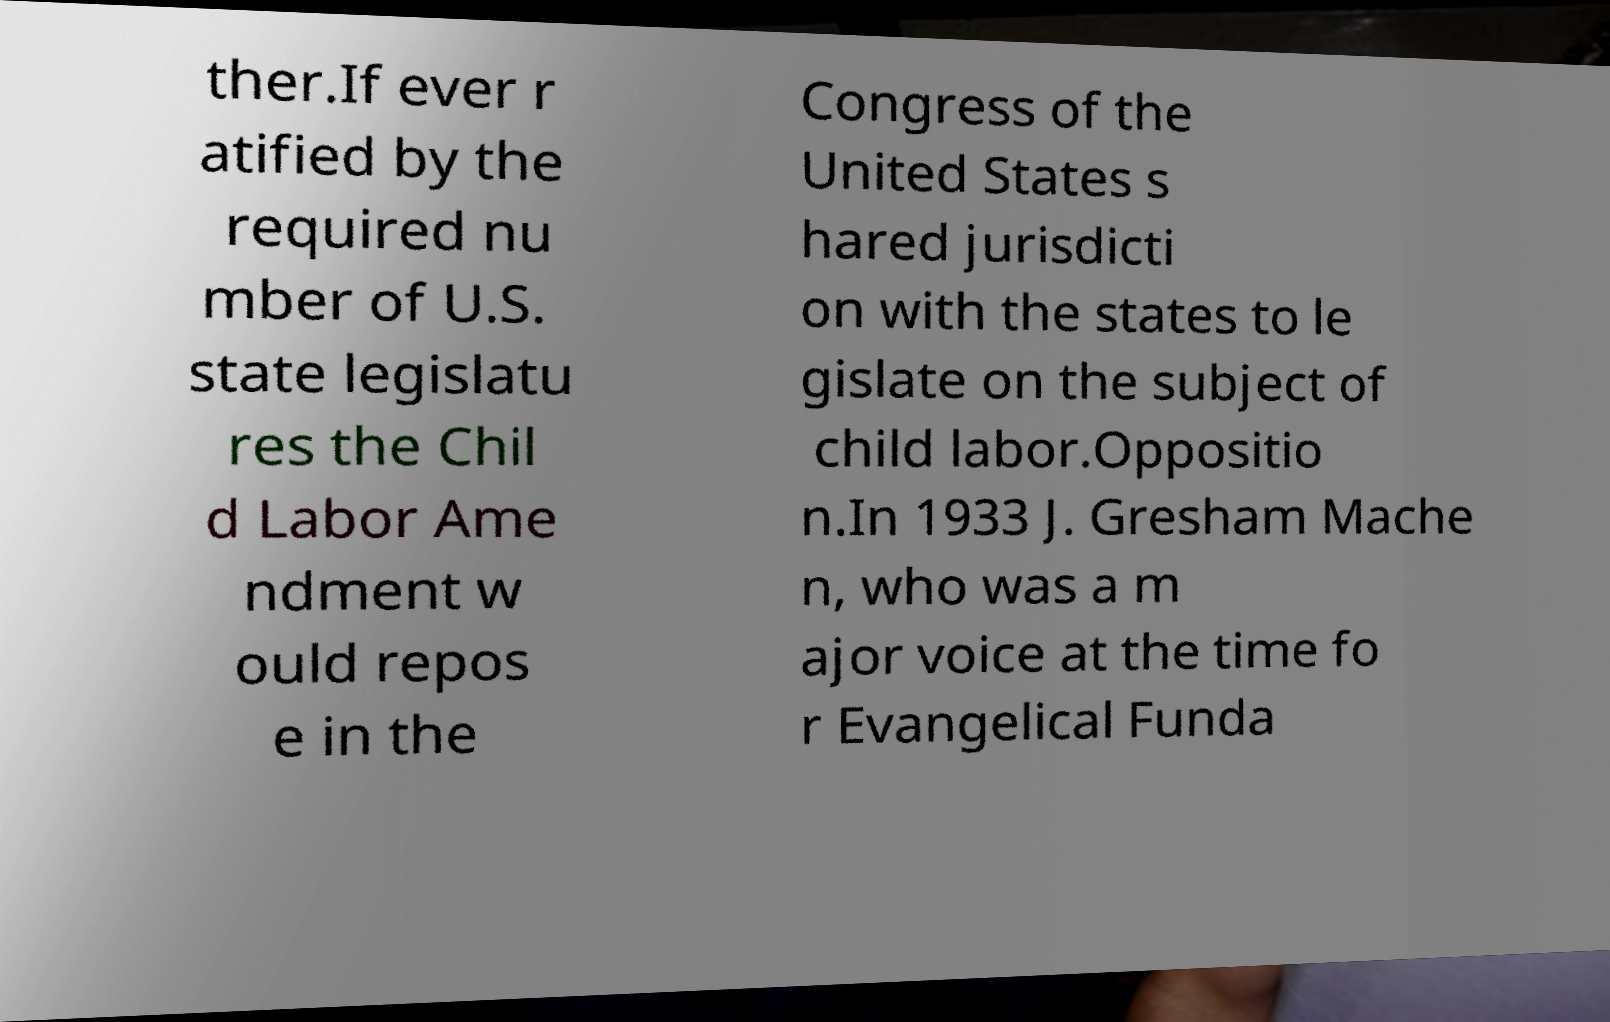What messages or text are displayed in this image? I need them in a readable, typed format. ther.If ever r atified by the required nu mber of U.S. state legislatu res the Chil d Labor Ame ndment w ould repos e in the Congress of the United States s hared jurisdicti on with the states to le gislate on the subject of child labor.Oppositio n.In 1933 J. Gresham Mache n, who was a m ajor voice at the time fo r Evangelical Funda 